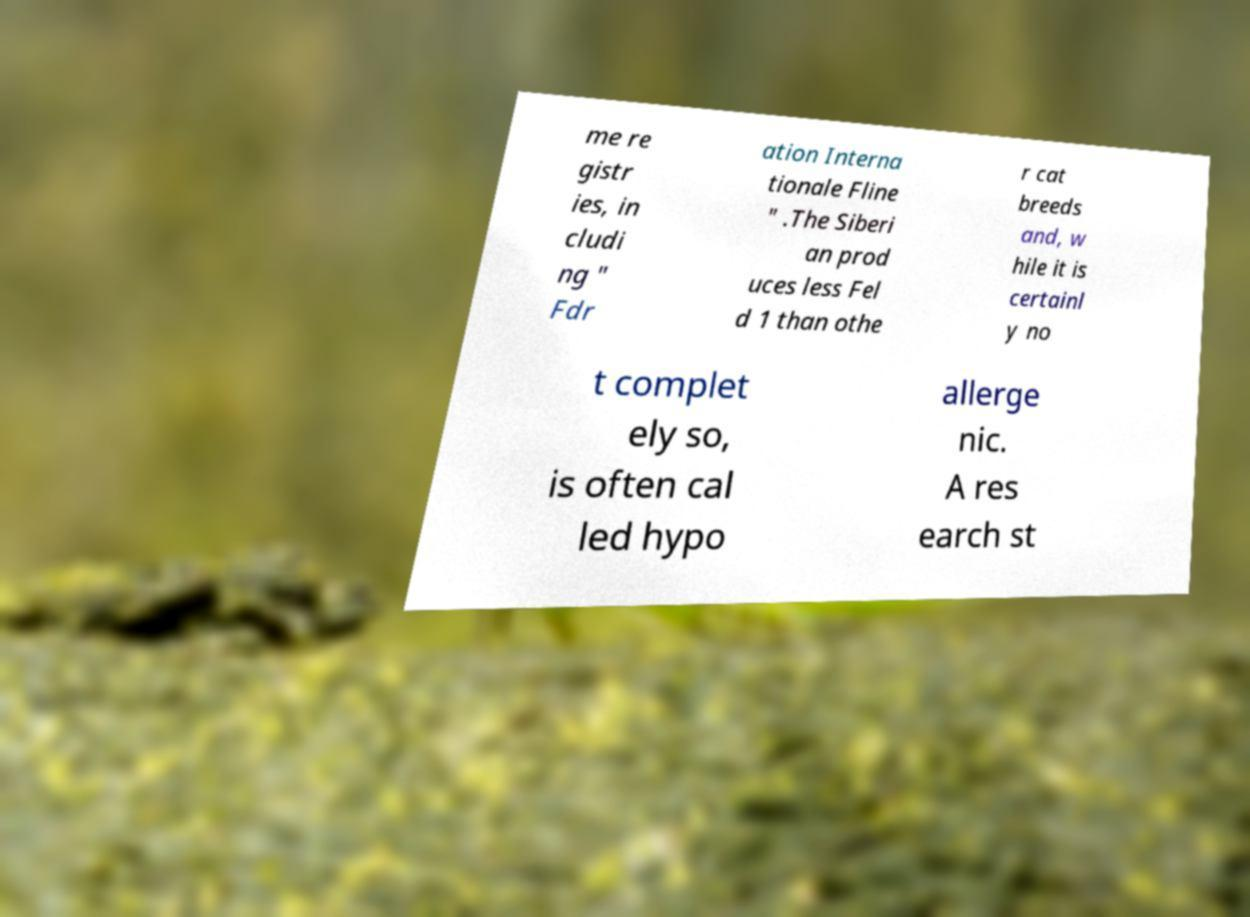Can you read and provide the text displayed in the image?This photo seems to have some interesting text. Can you extract and type it out for me? me re gistr ies, in cludi ng " Fdr ation Interna tionale Fline " .The Siberi an prod uces less Fel d 1 than othe r cat breeds and, w hile it is certainl y no t complet ely so, is often cal led hypo allerge nic. A res earch st 